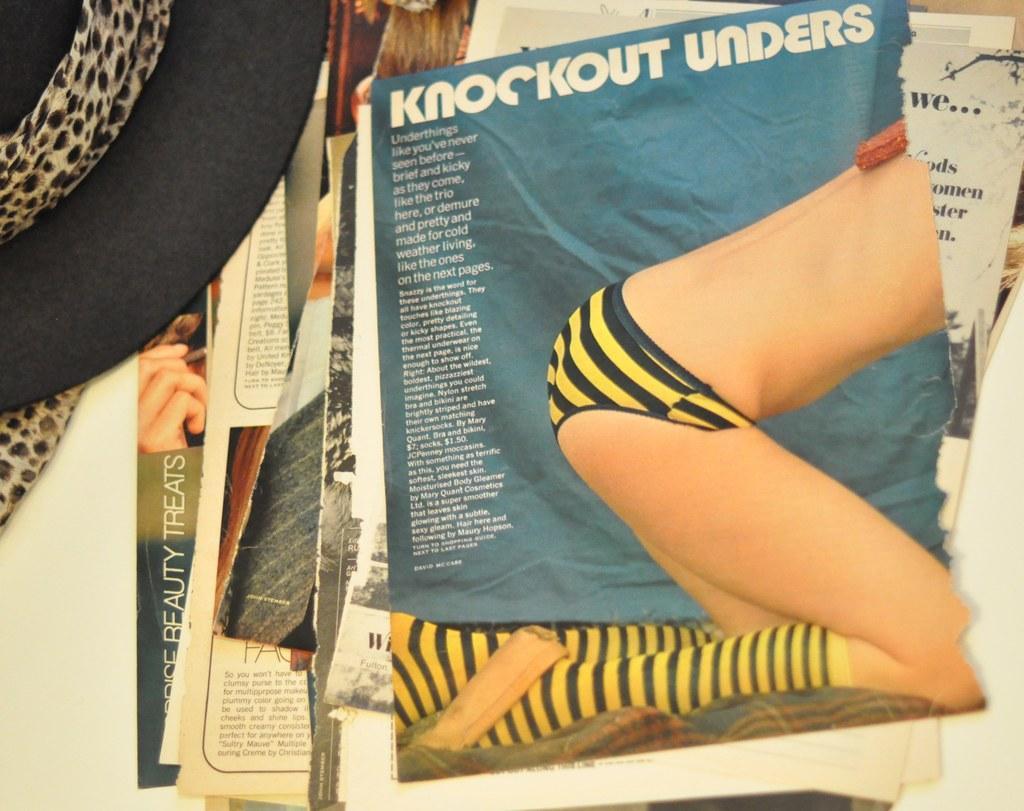In one or two sentences, can you explain what this image depicts? In this picture in the center there are papers with some text written on it and on the left side there is hat which is black in colour. 